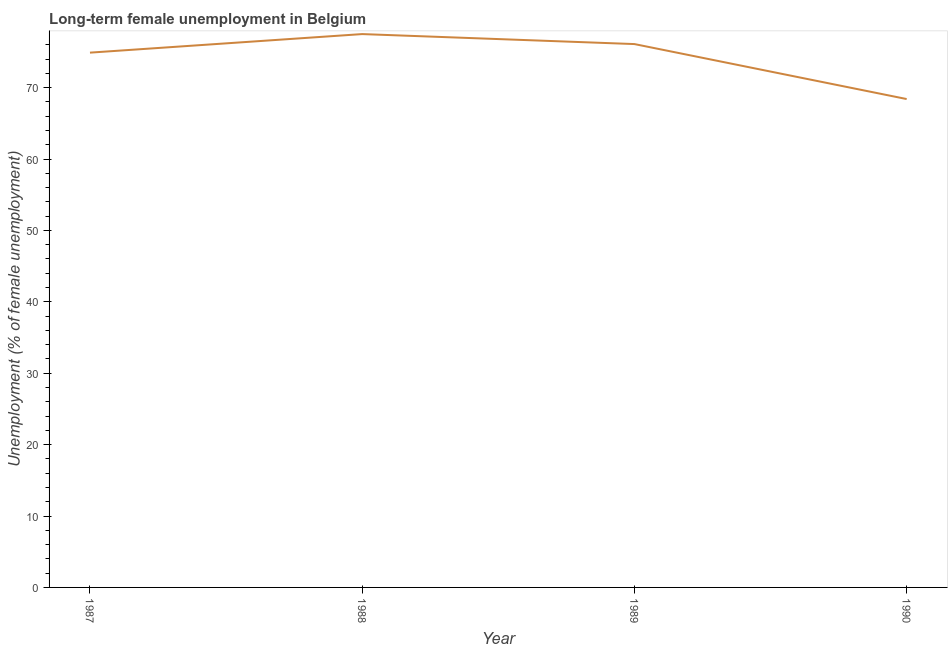What is the long-term female unemployment in 1988?
Your answer should be compact. 77.5. Across all years, what is the maximum long-term female unemployment?
Make the answer very short. 77.5. Across all years, what is the minimum long-term female unemployment?
Make the answer very short. 68.4. In which year was the long-term female unemployment minimum?
Your answer should be very brief. 1990. What is the sum of the long-term female unemployment?
Provide a short and direct response. 296.9. What is the difference between the long-term female unemployment in 1988 and 1990?
Your answer should be very brief. 9.1. What is the average long-term female unemployment per year?
Provide a short and direct response. 74.23. What is the median long-term female unemployment?
Your response must be concise. 75.5. In how many years, is the long-term female unemployment greater than 70 %?
Your answer should be very brief. 3. Do a majority of the years between 1990 and 1988 (inclusive) have long-term female unemployment greater than 38 %?
Provide a succinct answer. No. What is the ratio of the long-term female unemployment in 1987 to that in 1990?
Your response must be concise. 1.1. Is the difference between the long-term female unemployment in 1989 and 1990 greater than the difference between any two years?
Offer a very short reply. No. What is the difference between the highest and the second highest long-term female unemployment?
Provide a succinct answer. 1.4. What is the difference between the highest and the lowest long-term female unemployment?
Offer a terse response. 9.1. In how many years, is the long-term female unemployment greater than the average long-term female unemployment taken over all years?
Provide a succinct answer. 3. How many lines are there?
Offer a terse response. 1. How many years are there in the graph?
Offer a terse response. 4. What is the difference between two consecutive major ticks on the Y-axis?
Your answer should be compact. 10. Does the graph contain any zero values?
Make the answer very short. No. What is the title of the graph?
Ensure brevity in your answer.  Long-term female unemployment in Belgium. What is the label or title of the X-axis?
Make the answer very short. Year. What is the label or title of the Y-axis?
Offer a terse response. Unemployment (% of female unemployment). What is the Unemployment (% of female unemployment) in 1987?
Offer a terse response. 74.9. What is the Unemployment (% of female unemployment) of 1988?
Offer a terse response. 77.5. What is the Unemployment (% of female unemployment) of 1989?
Provide a succinct answer. 76.1. What is the Unemployment (% of female unemployment) in 1990?
Your answer should be very brief. 68.4. What is the difference between the Unemployment (% of female unemployment) in 1987 and 1988?
Give a very brief answer. -2.6. What is the ratio of the Unemployment (% of female unemployment) in 1987 to that in 1988?
Provide a short and direct response. 0.97. What is the ratio of the Unemployment (% of female unemployment) in 1987 to that in 1989?
Offer a terse response. 0.98. What is the ratio of the Unemployment (% of female unemployment) in 1987 to that in 1990?
Offer a very short reply. 1.09. What is the ratio of the Unemployment (% of female unemployment) in 1988 to that in 1990?
Ensure brevity in your answer.  1.13. What is the ratio of the Unemployment (% of female unemployment) in 1989 to that in 1990?
Your answer should be compact. 1.11. 